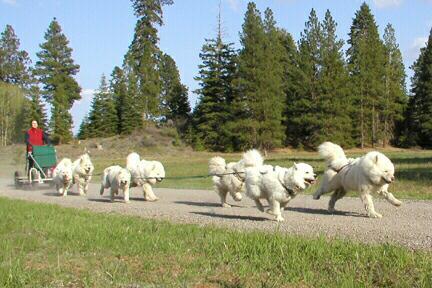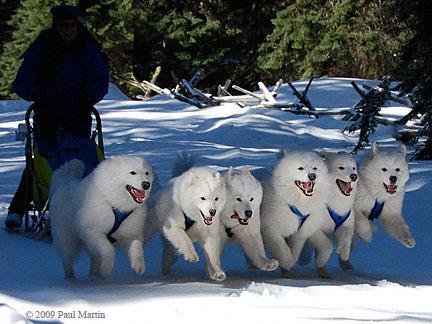The first image is the image on the left, the second image is the image on the right. Assess this claim about the two images: "There is exactly on dog in the image on the right.". Correct or not? Answer yes or no. No. 